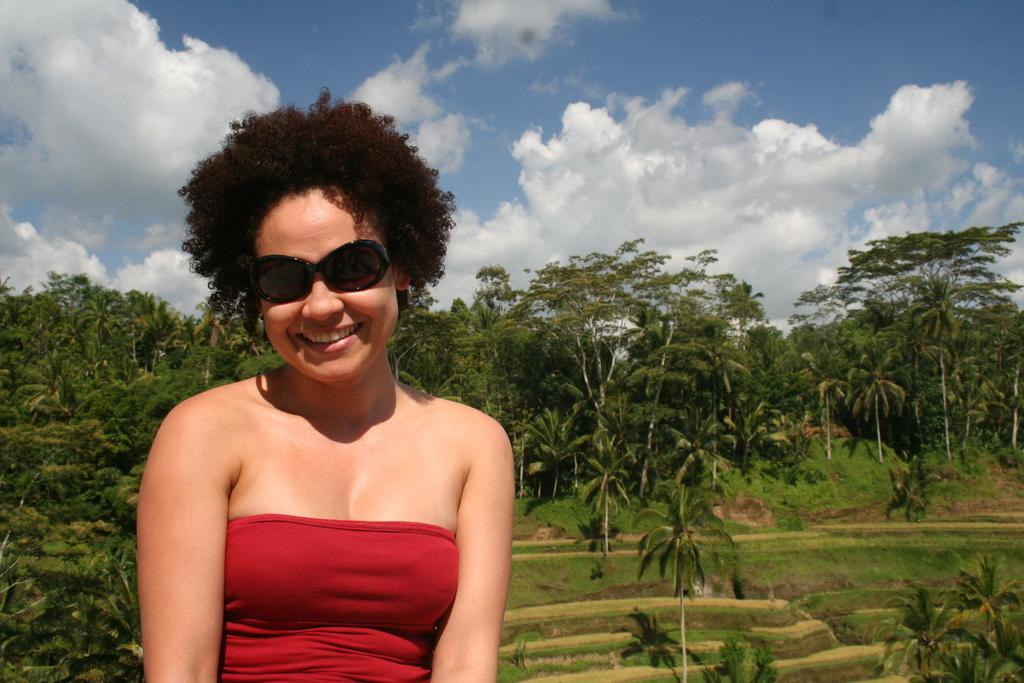Who is present in the image? There is a woman in the image. What is the woman wearing on her face? The woman is wearing sunglasses. What expression does the woman have? The woman is smiling. What type of natural environment can be seen in the image? There are trees visible in the image. How would you describe the sky in the image? The sky is blue and cloudy. What type of vein is visible on the woman's arm in the image? There is no visible vein on the woman's arm in the image. What sense does the woman appear to be experiencing in the image? The image does not provide information about the woman's senses. 